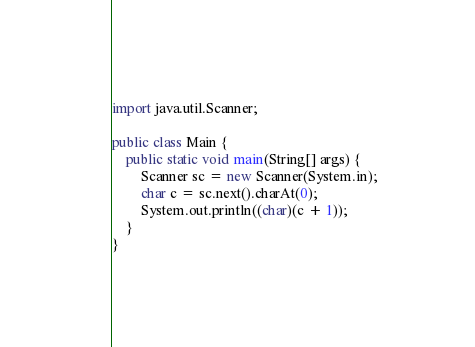<code> <loc_0><loc_0><loc_500><loc_500><_Java_>import java.util.Scanner;

public class Main {
    public static void main(String[] args) {
        Scanner sc = new Scanner(System.in);
        char c = sc.next().charAt(0);
        System.out.println((char)(c + 1));
    }
}
</code> 